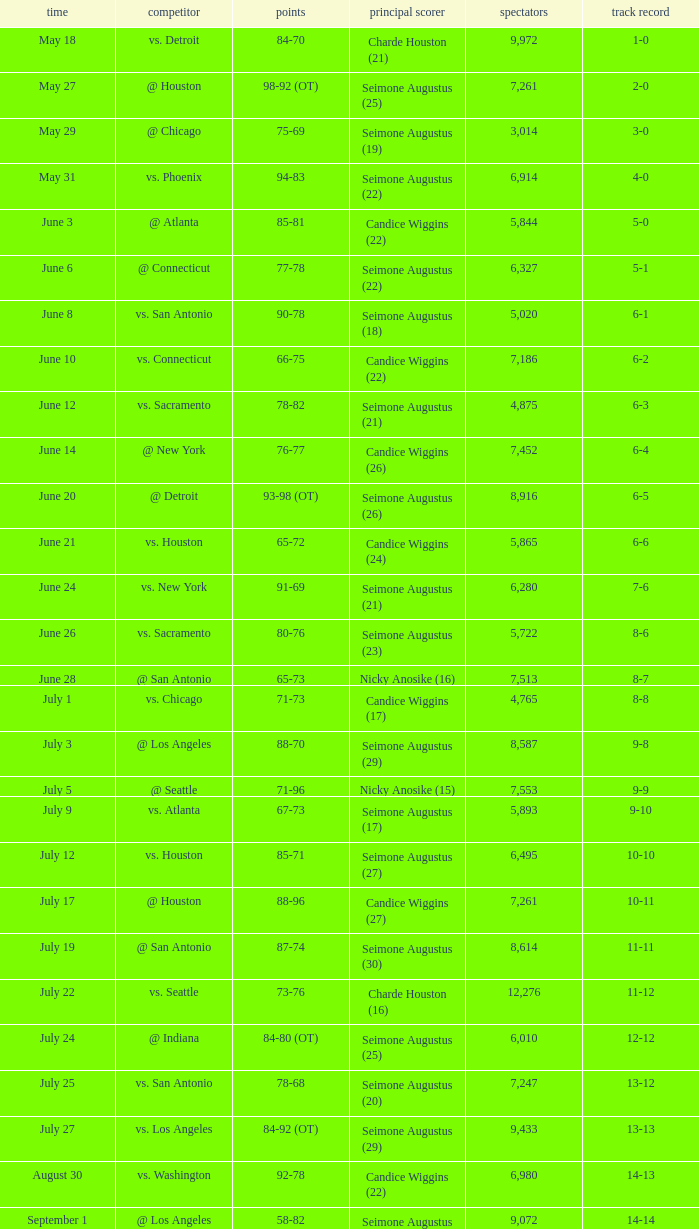Which Attendance has a Date of september 7? 7999.0. 